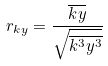<formula> <loc_0><loc_0><loc_500><loc_500>r _ { k y } = \frac { \overline { k y } } { \sqrt { \overline { k ^ { 3 } } \overline { y ^ { 3 } } } }</formula> 